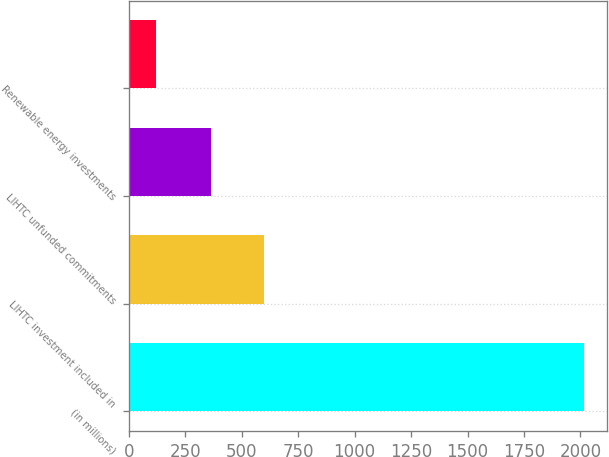<chart> <loc_0><loc_0><loc_500><loc_500><bar_chart><fcel>(in millions)<fcel>LIHTC investment included in<fcel>LIHTC unfunded commitments<fcel>Renewable energy investments<nl><fcel>2015<fcel>598<fcel>365<fcel>118<nl></chart> 